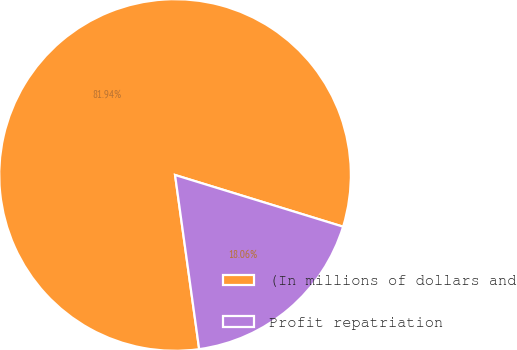Convert chart. <chart><loc_0><loc_0><loc_500><loc_500><pie_chart><fcel>(In millions of dollars and<fcel>Profit repatriation<nl><fcel>81.94%<fcel>18.06%<nl></chart> 